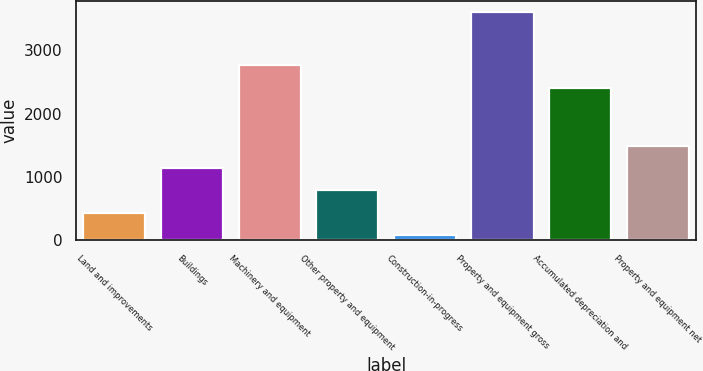Convert chart to OTSL. <chart><loc_0><loc_0><loc_500><loc_500><bar_chart><fcel>Land and improvements<fcel>Buildings<fcel>Machinery and equipment<fcel>Other property and equipment<fcel>Construction-in-progress<fcel>Property and equipment gross<fcel>Accumulated depreciation and<fcel>Property and equipment net<nl><fcel>437.84<fcel>1142.12<fcel>2765.04<fcel>789.98<fcel>85.7<fcel>3607.1<fcel>2412.9<fcel>1494.26<nl></chart> 